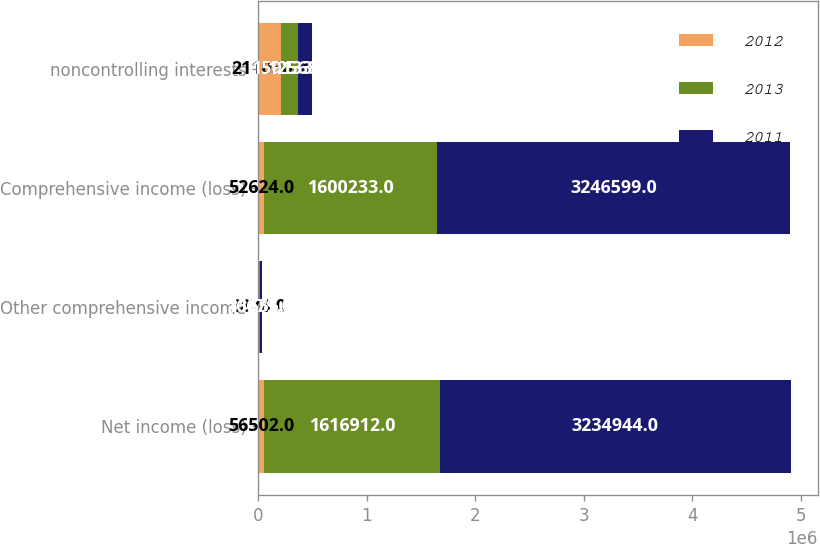Convert chart. <chart><loc_0><loc_0><loc_500><loc_500><stacked_bar_chart><ecel><fcel>Net income (loss)<fcel>Other comprehensive income<fcel>Comprehensive income (loss)<fcel>noncontrolling interests<nl><fcel>2012<fcel>56502<fcel>3878<fcel>52624<fcel>211030<nl><fcel>2013<fcel>1.61691e+06<fcel>16679<fcel>1.60023e+06<fcel>159133<nl><fcel>2011<fcel>3.23494e+06<fcel>11655<fcel>3.2466e+06<fcel>125683<nl></chart> 